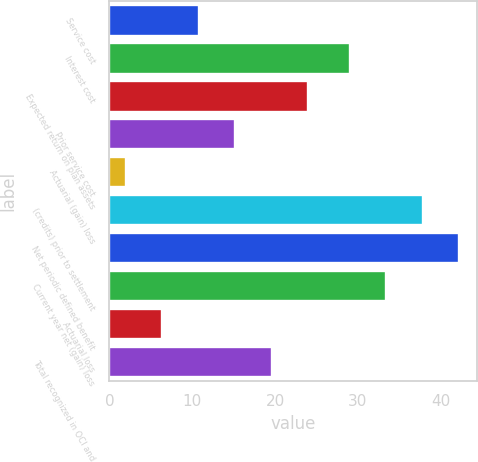<chart> <loc_0><loc_0><loc_500><loc_500><bar_chart><fcel>Service cost<fcel>Interest cost<fcel>Expected return on plan assets<fcel>Prior service cost<fcel>Actuarial (gain) loss<fcel>(credits) prior to settlement<fcel>Net periodic defined benefit<fcel>Current year net (gain) loss<fcel>Actuarial loss<fcel>Total recognized in OCI and<nl><fcel>10.8<fcel>29<fcel>24<fcel>15.2<fcel>2<fcel>37.8<fcel>42.2<fcel>33.4<fcel>6.4<fcel>19.6<nl></chart> 